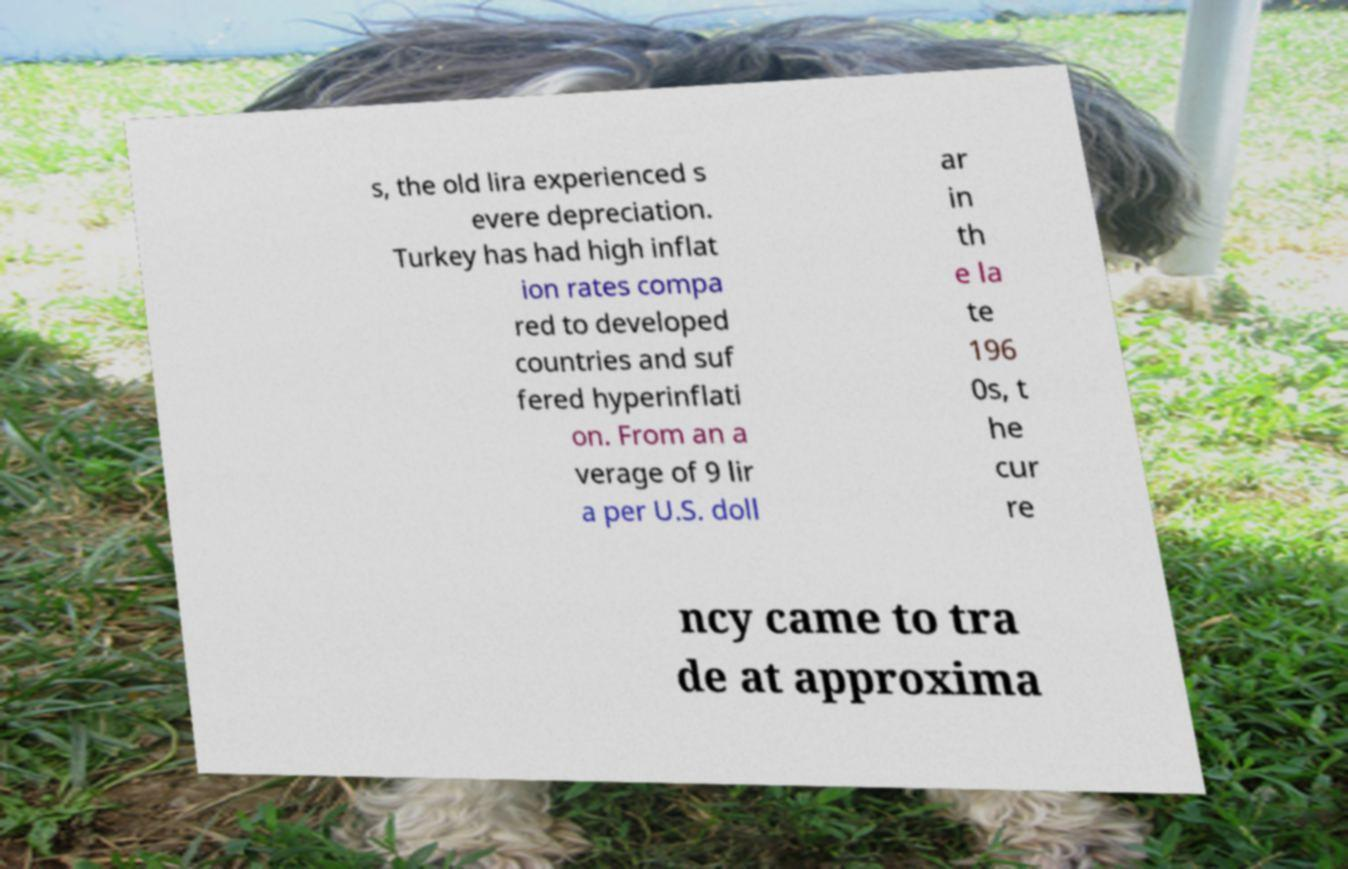Could you extract and type out the text from this image? s, the old lira experienced s evere depreciation. Turkey has had high inflat ion rates compa red to developed countries and suf fered hyperinflati on. From an a verage of 9 lir a per U.S. doll ar in th e la te 196 0s, t he cur re ncy came to tra de at approxima 